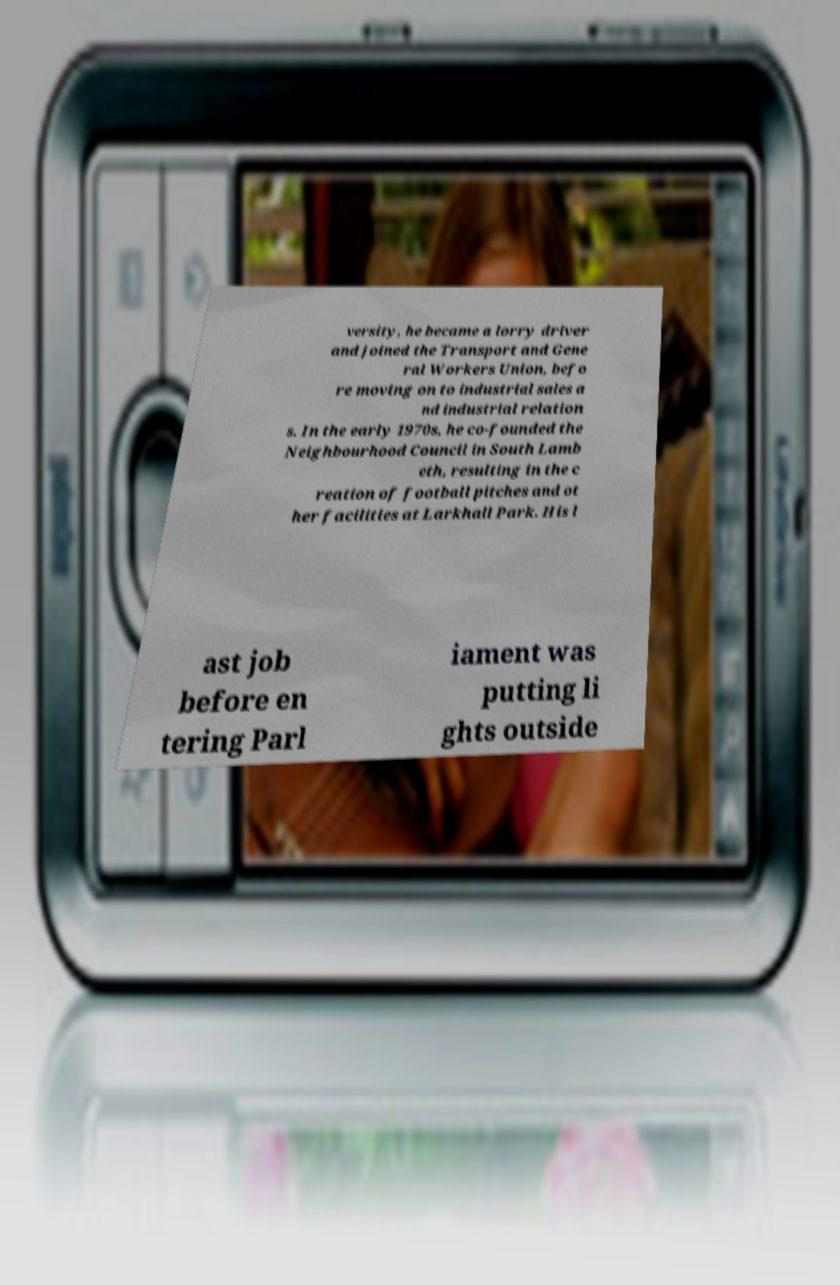What messages or text are displayed in this image? I need them in a readable, typed format. versity, he became a lorry driver and joined the Transport and Gene ral Workers Union, befo re moving on to industrial sales a nd industrial relation s. In the early 1970s, he co-founded the Neighbourhood Council in South Lamb eth, resulting in the c reation of football pitches and ot her facilities at Larkhall Park. His l ast job before en tering Parl iament was putting li ghts outside 